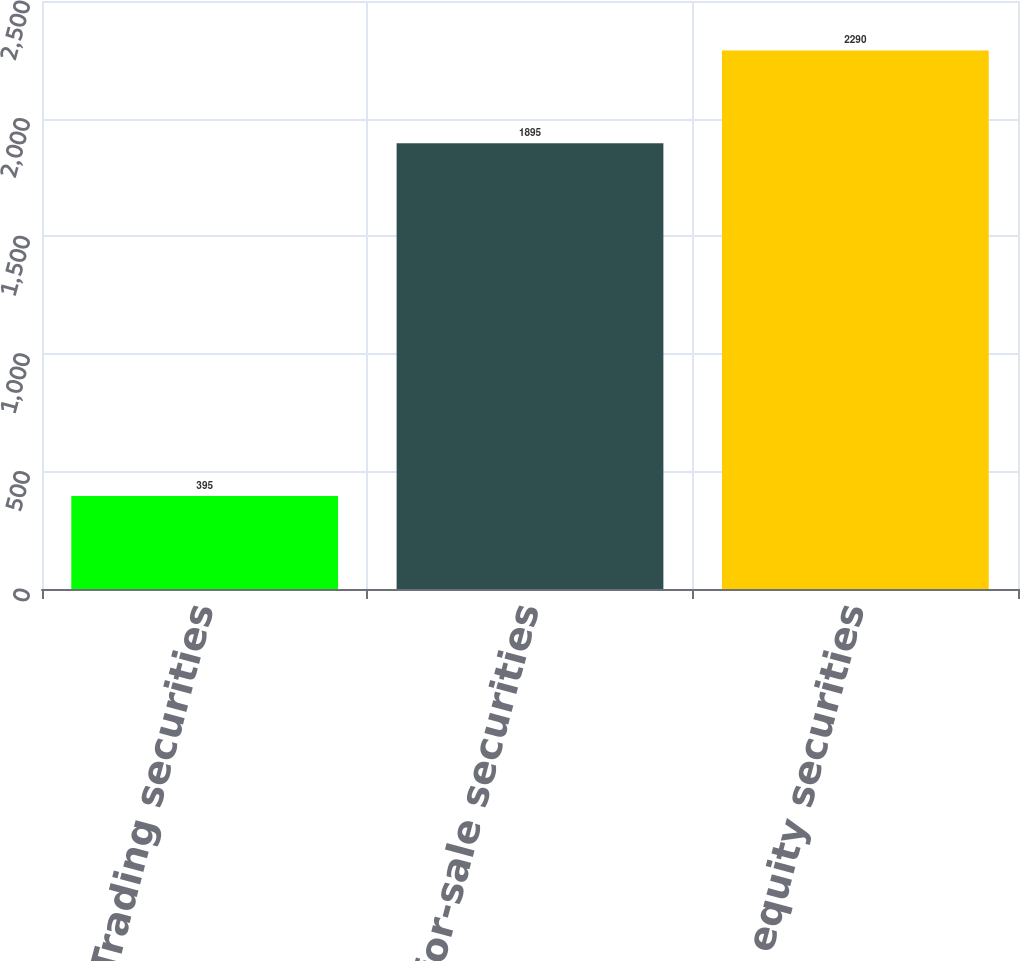Convert chart to OTSL. <chart><loc_0><loc_0><loc_500><loc_500><bar_chart><fcel>Trading securities<fcel>Available-for-sale securities<fcel>Total equity securities<nl><fcel>395<fcel>1895<fcel>2290<nl></chart> 